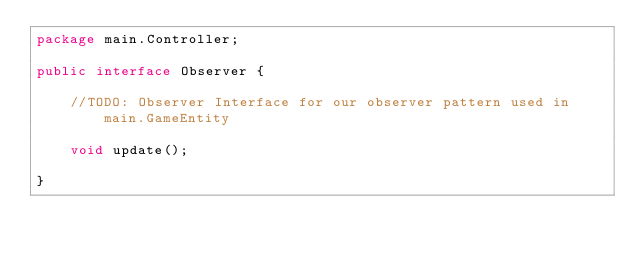Convert code to text. <code><loc_0><loc_0><loc_500><loc_500><_Java_>package main.Controller;

public interface Observer {

    //TODO: Observer Interface for our observer pattern used in main.GameEntity

    void update();

}
</code> 